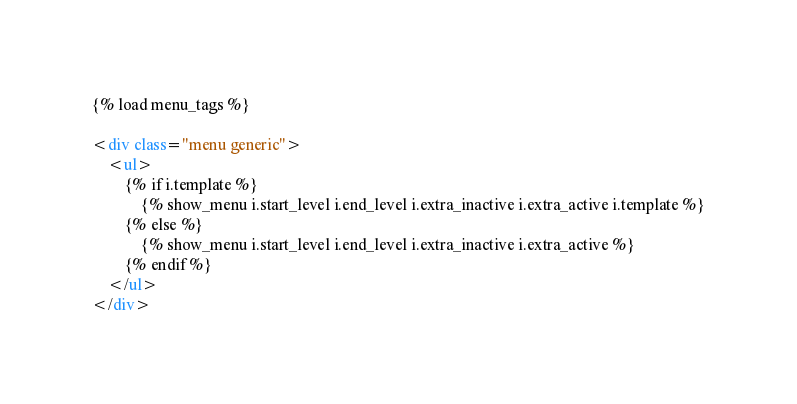<code> <loc_0><loc_0><loc_500><loc_500><_HTML_>{% load menu_tags %}

<div class="menu generic">
    <ul>
        {% if i.template %}
            {% show_menu i.start_level i.end_level i.extra_inactive i.extra_active i.template %}
        {% else %}
            {% show_menu i.start_level i.end_level i.extra_inactive i.extra_active %}
        {% endif %}
    </ul>
</div>
</code> 